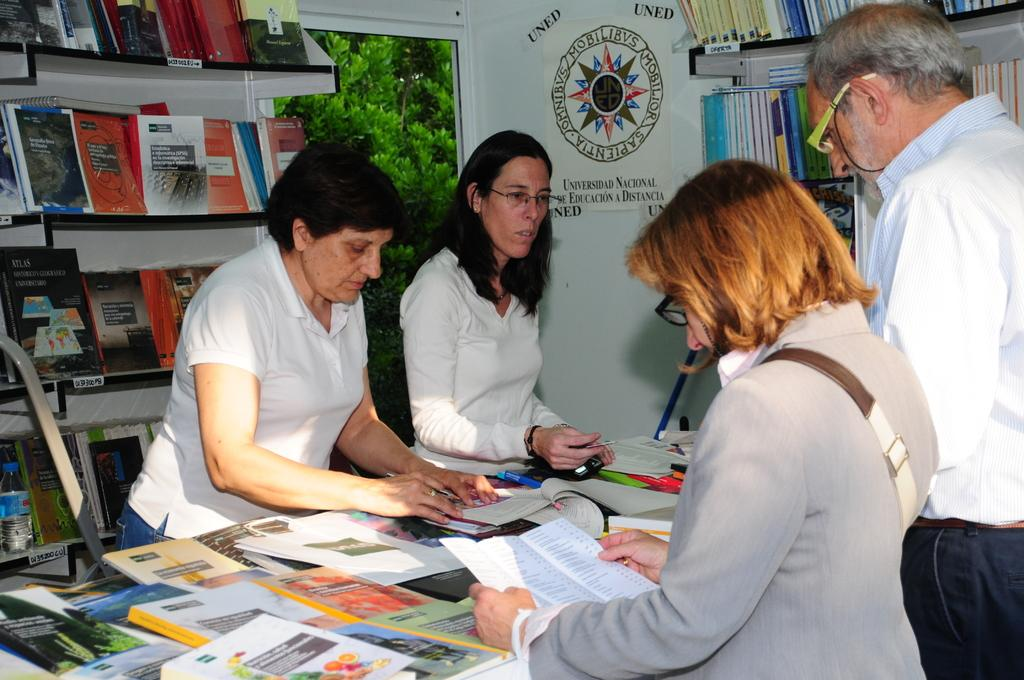<image>
Render a clear and concise summary of the photo. A group of people standing at a table pouring over books with a sign in the background that says Universidad Nacional. 